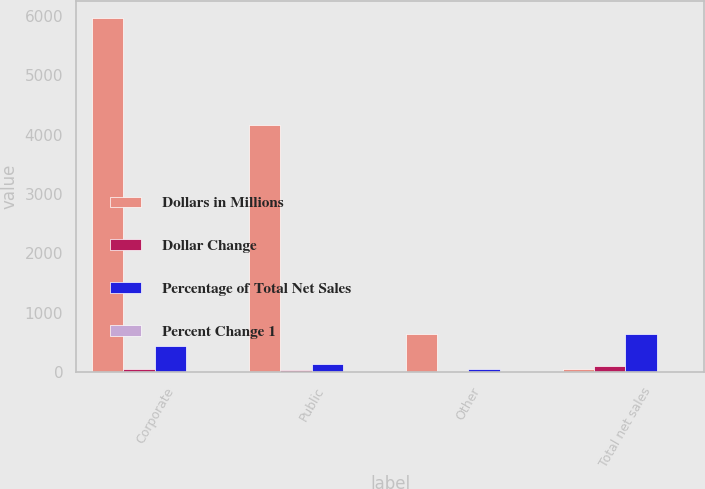Convert chart to OTSL. <chart><loc_0><loc_0><loc_500><loc_500><stacked_bar_chart><ecel><fcel>Corporate<fcel>Public<fcel>Other<fcel>Total net sales<nl><fcel>Dollars in Millions<fcel>5960.1<fcel>4164.5<fcel>644<fcel>55.3<nl><fcel>Dollar Change<fcel>55.3<fcel>38.7<fcel>6<fcel>100<nl><fcel>Percentage of Total Net Sales<fcel>447.3<fcel>141.5<fcel>51.6<fcel>640.4<nl><fcel>Percent Change 1<fcel>8.1<fcel>3.5<fcel>8.7<fcel>6.3<nl></chart> 